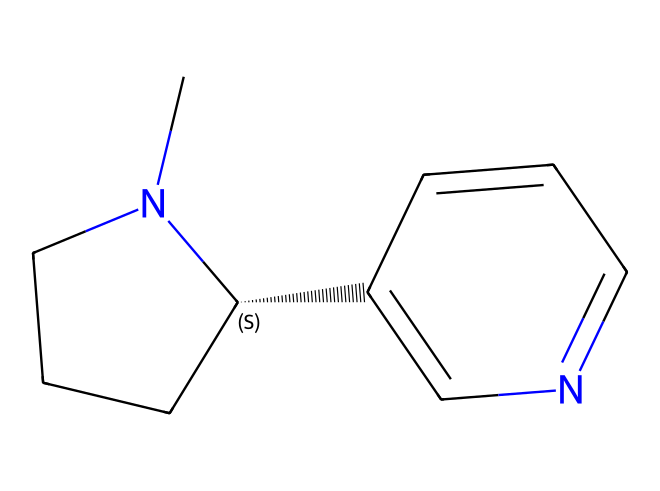What is the molecular formula of this compound? To find the molecular formula, we must count the number of each type of atom in the structure represented by the SMILES. Analyzing the SMILES, we can determine there are 10 carbon atoms, 14 hydrogen atoms, 1 nitrogen atom, and 1 additional nitrogen in the ring structure, leading us to C10H14N2.
Answer: C10H14N2 How many nitrogen atoms are present? The SMILES indicates there are two nitrogen atoms in the structure. They can be identified visually by examining the positions and representations of the nitrogen (N) in the SMILES notation.
Answer: 2 What type of compound is nicotine classified as? Based on its structure and the presence of nitrogen, nicotine is classified as an alkaloid. Alkaloids are typically derived from plant sources and contain basic nitrogen atoms which give them their characteristics.
Answer: alkaloid Does this compound exhibit aromaticity? The chemical structure indicates the presence of a cyclic system with alternating double bonds, which is characteristic of aromatic compounds. This is concluded by analyzing the ring structure and presence of pi bonding in the cyclic section of the molecule.
Answer: yes What functional groups are present in nicotine? The SMILES structure reveals that the compound contains a pyridine ring (due to the nitrogen within a six-membered ring) along with a piperidine ring. These recognize the functional groups that are associated with carbon and nitrogen atoms in the structure.
Answer: pyridine and piperidine What is the total number of rings in nicotine? By examining the structure represented in the SMILES, we can see two distinct ring structures: one is the piperidine ring and the other is the pyridine ring; thus, the total is two rings.
Answer: 2 